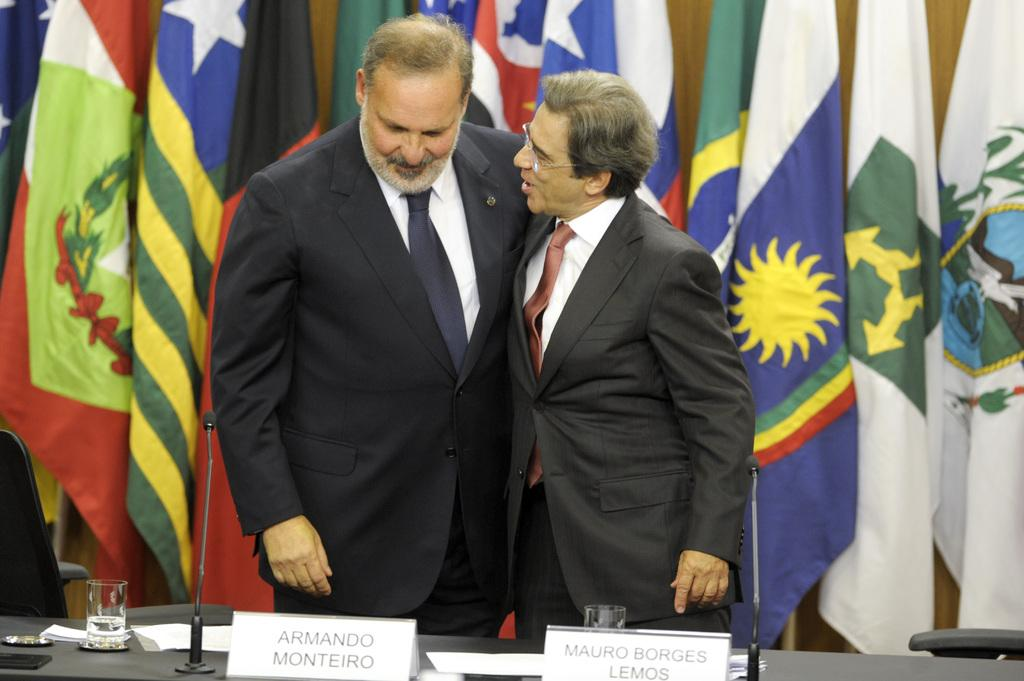What type of people can be seen in the image? There are women standing in the image. What objects are present in the image that might be related to a gathering or event? There are flags and a microphone in the image. What objects in the image might be used for drinking or holding a liquid? There is a glass in the image. What objects in the image might be used for writing or displaying information? There is a paper in the image. What type of powder can be seen on the women's faces in the image? There is no powder visible on the women's faces in the image. Can you tell me the weight of the cat sitting on the glass in the image? There is no cat present in the image, so it is not possible to determine its weight. 